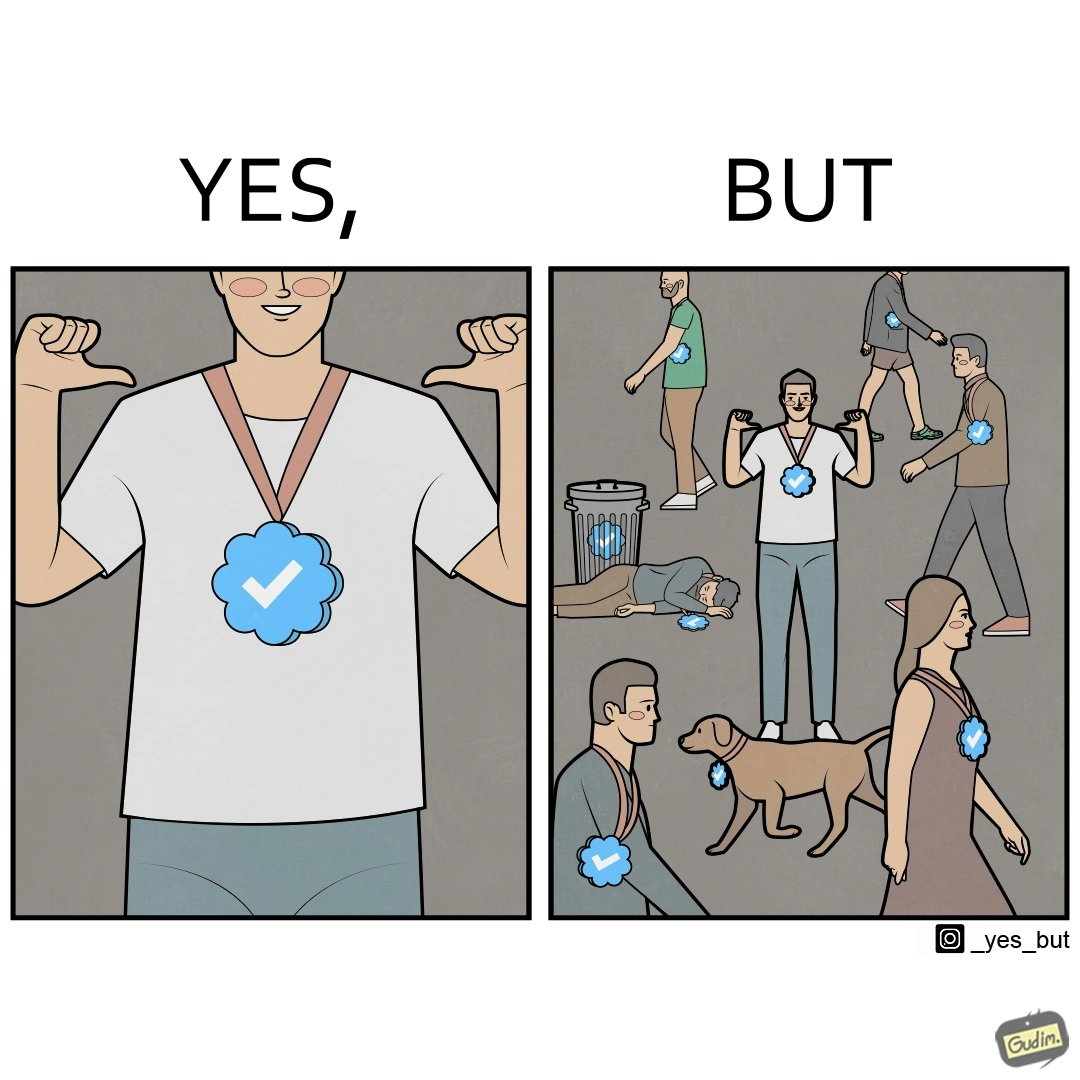What is shown in the left half versus the right half of this image? In the left part of the image: It is a man with a medal In the right part of the image: There are many humans and animals with the same medal 